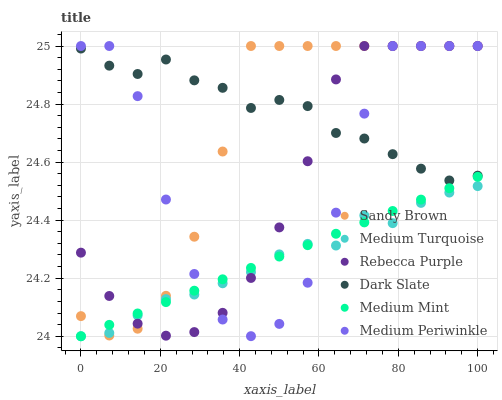Does Medium Turquoise have the minimum area under the curve?
Answer yes or no. Yes. Does Dark Slate have the maximum area under the curve?
Answer yes or no. Yes. Does Medium Periwinkle have the minimum area under the curve?
Answer yes or no. No. Does Medium Periwinkle have the maximum area under the curve?
Answer yes or no. No. Is Medium Mint the smoothest?
Answer yes or no. Yes. Is Medium Periwinkle the roughest?
Answer yes or no. Yes. Is Dark Slate the smoothest?
Answer yes or no. No. Is Dark Slate the roughest?
Answer yes or no. No. Does Medium Mint have the lowest value?
Answer yes or no. Yes. Does Medium Periwinkle have the lowest value?
Answer yes or no. No. Does Sandy Brown have the highest value?
Answer yes or no. Yes. Does Dark Slate have the highest value?
Answer yes or no. No. Is Medium Turquoise less than Dark Slate?
Answer yes or no. Yes. Is Dark Slate greater than Medium Mint?
Answer yes or no. Yes. Does Rebecca Purple intersect Medium Periwinkle?
Answer yes or no. Yes. Is Rebecca Purple less than Medium Periwinkle?
Answer yes or no. No. Is Rebecca Purple greater than Medium Periwinkle?
Answer yes or no. No. Does Medium Turquoise intersect Dark Slate?
Answer yes or no. No. 